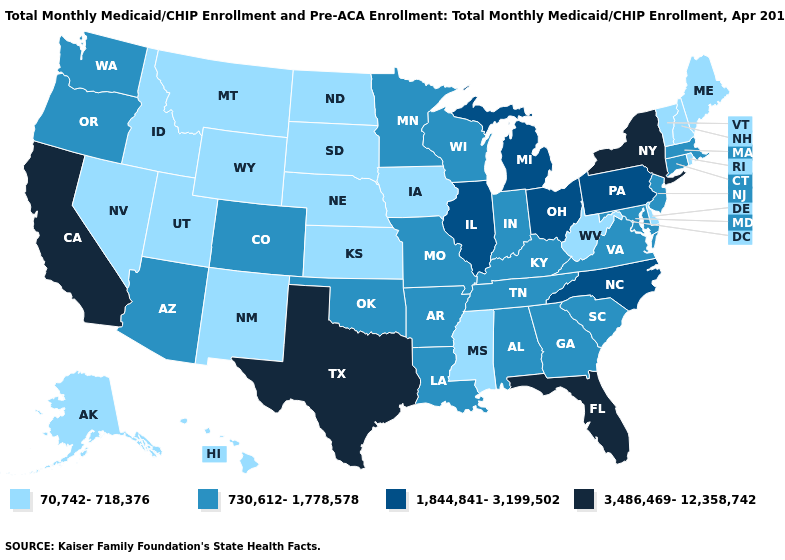What is the highest value in the USA?
Give a very brief answer. 3,486,469-12,358,742. Does the first symbol in the legend represent the smallest category?
Be succinct. Yes. What is the value of Missouri?
Keep it brief. 730,612-1,778,578. What is the value of Oklahoma?
Short answer required. 730,612-1,778,578. Does Pennsylvania have the lowest value in the Northeast?
Be succinct. No. What is the value of Massachusetts?
Concise answer only. 730,612-1,778,578. How many symbols are there in the legend?
Answer briefly. 4. What is the value of Rhode Island?
Give a very brief answer. 70,742-718,376. Which states have the lowest value in the West?
Answer briefly. Alaska, Hawaii, Idaho, Montana, Nevada, New Mexico, Utah, Wyoming. What is the value of Indiana?
Short answer required. 730,612-1,778,578. Among the states that border Oklahoma , which have the lowest value?
Quick response, please. Kansas, New Mexico. Name the states that have a value in the range 730,612-1,778,578?
Short answer required. Alabama, Arizona, Arkansas, Colorado, Connecticut, Georgia, Indiana, Kentucky, Louisiana, Maryland, Massachusetts, Minnesota, Missouri, New Jersey, Oklahoma, Oregon, South Carolina, Tennessee, Virginia, Washington, Wisconsin. What is the value of Wisconsin?
Give a very brief answer. 730,612-1,778,578. Which states have the lowest value in the West?
Write a very short answer. Alaska, Hawaii, Idaho, Montana, Nevada, New Mexico, Utah, Wyoming. Name the states that have a value in the range 1,844,841-3,199,502?
Give a very brief answer. Illinois, Michigan, North Carolina, Ohio, Pennsylvania. 